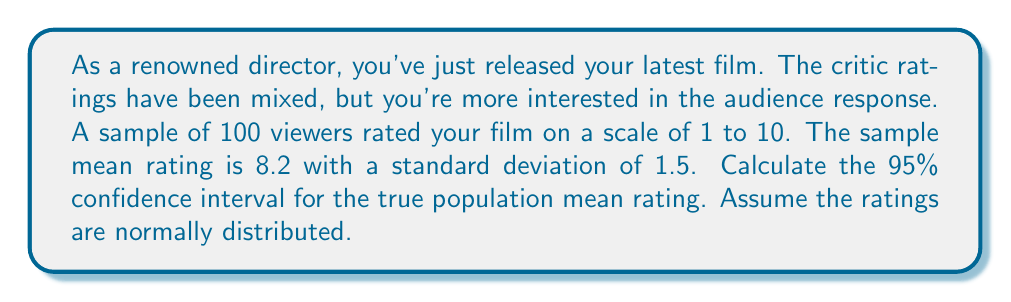Can you solve this math problem? To calculate the confidence interval, we'll use the formula:

$$ \text{CI} = \bar{x} \pm t_{\frac{\alpha}{2}, n-1} \cdot \frac{s}{\sqrt{n}} $$

Where:
$\bar{x}$ = sample mean = 8.2
$s$ = sample standard deviation = 1.5
$n$ = sample size = 100
$t_{\frac{\alpha}{2}, n-1}$ = t-value for 95% confidence level with 99 degrees of freedom

Steps:
1) For a 95% confidence level, $\alpha = 0.05$
2) Degrees of freedom = $n - 1 = 99$
3) From t-table, $t_{0.025, 99} \approx 1.984$
4) Calculate standard error: $\frac{s}{\sqrt{n}} = \frac{1.5}{\sqrt{100}} = 0.15$
5) Calculate margin of error: $1.984 \cdot 0.15 = 0.2976$
6) Lower bound: $8.2 - 0.2976 = 7.9024$
7) Upper bound: $8.2 + 0.2976 = 8.4976$

Therefore, the 95% confidence interval is (7.9024, 8.4976).
Answer: (7.90, 8.50) 